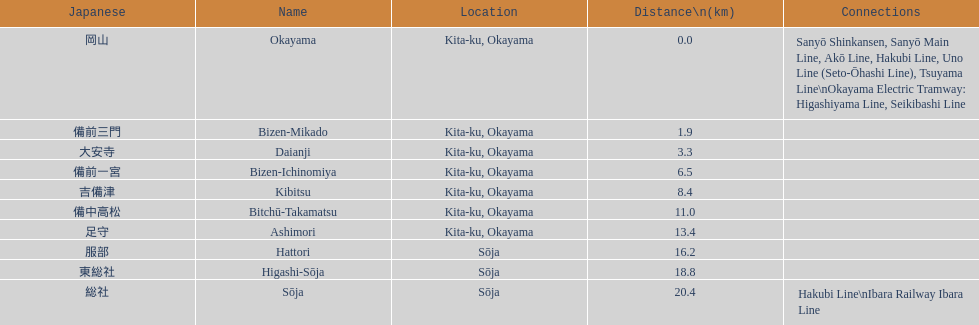How many consecutive stops must you travel through is you board the kibi line at bizen-mikado at depart at kibitsu? 2. 